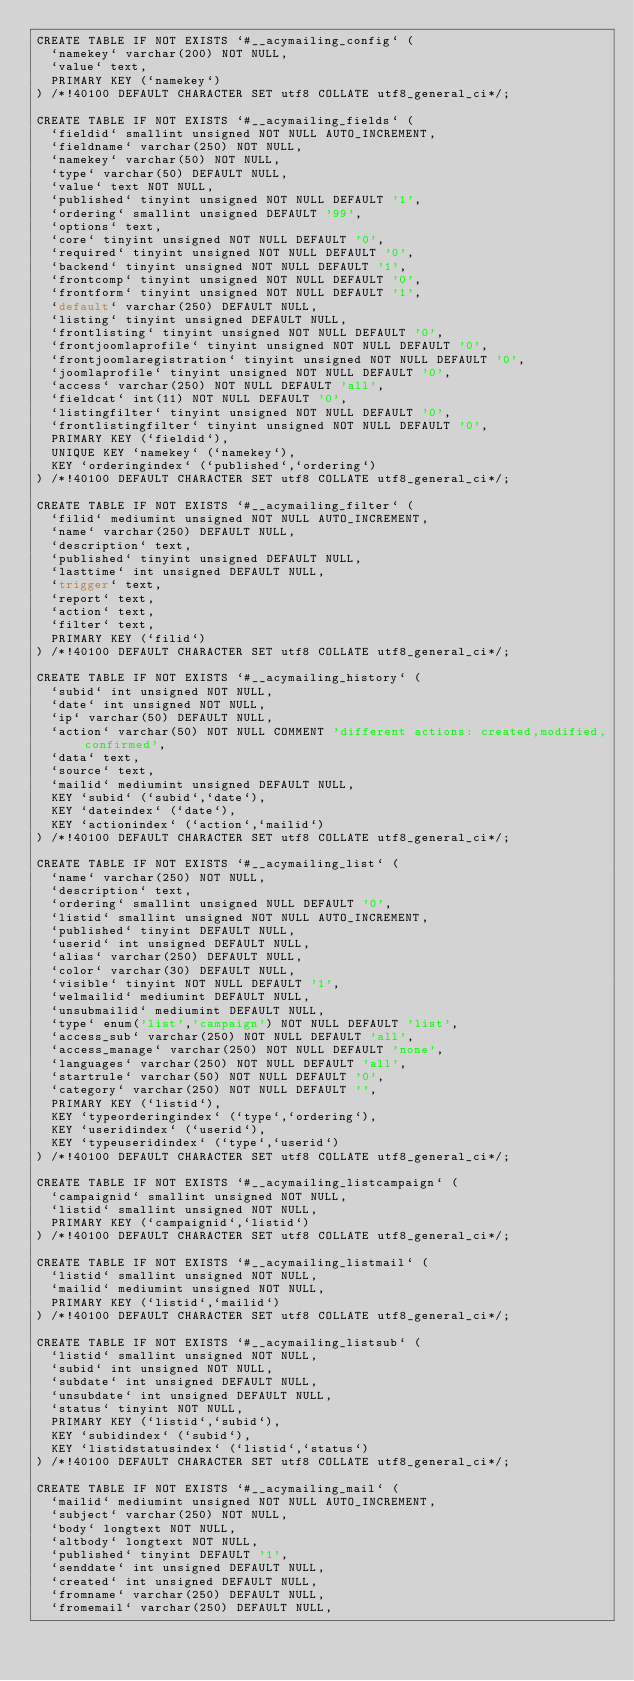Convert code to text. <code><loc_0><loc_0><loc_500><loc_500><_SQL_>CREATE TABLE IF NOT EXISTS `#__acymailing_config` (
	`namekey` varchar(200) NOT NULL,
	`value` text,
	PRIMARY KEY (`namekey`)
) /*!40100 DEFAULT CHARACTER SET utf8 COLLATE utf8_general_ci*/;

CREATE TABLE IF NOT EXISTS `#__acymailing_fields` (
	`fieldid` smallint unsigned NOT NULL AUTO_INCREMENT,
	`fieldname` varchar(250) NOT NULL,
	`namekey` varchar(50) NOT NULL,
	`type` varchar(50) DEFAULT NULL,
	`value` text NOT NULL,
	`published` tinyint unsigned NOT NULL DEFAULT '1',
	`ordering` smallint unsigned DEFAULT '99',
	`options` text,
	`core` tinyint unsigned NOT NULL DEFAULT '0',
	`required` tinyint unsigned NOT NULL DEFAULT '0',
	`backend` tinyint unsigned NOT NULL DEFAULT '1',
	`frontcomp` tinyint unsigned NOT NULL DEFAULT '0',
	`frontform` tinyint unsigned NOT NULL DEFAULT '1',
	`default` varchar(250) DEFAULT NULL,
	`listing` tinyint unsigned DEFAULT NULL,
	`frontlisting` tinyint unsigned NOT NULL DEFAULT '0',
	`frontjoomlaprofile` tinyint unsigned NOT NULL DEFAULT '0',
	`frontjoomlaregistration` tinyint unsigned NOT NULL DEFAULT '0',
	`joomlaprofile` tinyint unsigned NOT NULL DEFAULT '0',
	`access` varchar(250) NOT NULL DEFAULT 'all',
	`fieldcat` int(11) NOT NULL DEFAULT '0',
	`listingfilter` tinyint unsigned NOT NULL DEFAULT '0',
	`frontlistingfilter` tinyint unsigned NOT NULL DEFAULT '0',
	PRIMARY KEY (`fieldid`),
	UNIQUE KEY `namekey` (`namekey`),
	KEY `orderingindex` (`published`,`ordering`)
) /*!40100 DEFAULT CHARACTER SET utf8 COLLATE utf8_general_ci*/;

CREATE TABLE IF NOT EXISTS `#__acymailing_filter` (
	`filid` mediumint unsigned NOT NULL AUTO_INCREMENT,
	`name` varchar(250) DEFAULT NULL,
	`description` text,
	`published` tinyint unsigned DEFAULT NULL,
	`lasttime` int unsigned DEFAULT NULL,
	`trigger` text,
	`report` text,
	`action` text,
	`filter` text,
	PRIMARY KEY (`filid`)
) /*!40100 DEFAULT CHARACTER SET utf8 COLLATE utf8_general_ci*/;

CREATE TABLE IF NOT EXISTS `#__acymailing_history` (
	`subid` int unsigned NOT NULL,
	`date` int unsigned NOT NULL,
	`ip` varchar(50) DEFAULT NULL,
	`action` varchar(50) NOT NULL COMMENT 'different actions: created,modified,confirmed',
	`data` text,
	`source` text,
	`mailid` mediumint unsigned DEFAULT NULL,
	KEY `subid` (`subid`,`date`),
	KEY `dateindex` (`date`),
	KEY `actionindex` (`action`,`mailid`)
) /*!40100 DEFAULT CHARACTER SET utf8 COLLATE utf8_general_ci*/;

CREATE TABLE IF NOT EXISTS `#__acymailing_list` (
	`name` varchar(250) NOT NULL,
	`description` text,
	`ordering` smallint unsigned NULL DEFAULT '0',
	`listid` smallint unsigned NOT NULL AUTO_INCREMENT,
	`published` tinyint DEFAULT NULL,
	`userid` int unsigned DEFAULT NULL,
	`alias` varchar(250) DEFAULT NULL,
	`color` varchar(30) DEFAULT NULL,
	`visible` tinyint NOT NULL DEFAULT '1',
	`welmailid` mediumint DEFAULT NULL,
	`unsubmailid` mediumint DEFAULT NULL,
	`type` enum('list','campaign') NOT NULL DEFAULT 'list',
	`access_sub` varchar(250) NOT NULL DEFAULT 'all',
	`access_manage` varchar(250) NOT NULL DEFAULT 'none',
	`languages` varchar(250) NOT NULL DEFAULT 'all',
	`startrule` varchar(50) NOT NULL DEFAULT '0',
	`category` varchar(250) NOT NULL DEFAULT '',
	PRIMARY KEY (`listid`),
	KEY `typeorderingindex` (`type`,`ordering`),
	KEY `useridindex` (`userid`),
	KEY `typeuseridindex` (`type`,`userid`)
) /*!40100 DEFAULT CHARACTER SET utf8 COLLATE utf8_general_ci*/;

CREATE TABLE IF NOT EXISTS `#__acymailing_listcampaign` (
	`campaignid` smallint unsigned NOT NULL,
	`listid` smallint unsigned NOT NULL,
	PRIMARY KEY (`campaignid`,`listid`)
) /*!40100 DEFAULT CHARACTER SET utf8 COLLATE utf8_general_ci*/;

CREATE TABLE IF NOT EXISTS `#__acymailing_listmail` (
	`listid` smallint unsigned NOT NULL,
	`mailid` mediumint unsigned NOT NULL,
	PRIMARY KEY (`listid`,`mailid`)
) /*!40100 DEFAULT CHARACTER SET utf8 COLLATE utf8_general_ci*/;

CREATE TABLE IF NOT EXISTS `#__acymailing_listsub` (
	`listid` smallint unsigned NOT NULL,
	`subid` int unsigned NOT NULL,
	`subdate` int unsigned DEFAULT NULL,
	`unsubdate` int unsigned DEFAULT NULL,
	`status` tinyint NOT NULL,
	PRIMARY KEY (`listid`,`subid`),
	KEY `subidindex` (`subid`),
	KEY `listidstatusindex` (`listid`,`status`)
) /*!40100 DEFAULT CHARACTER SET utf8 COLLATE utf8_general_ci*/;

CREATE TABLE IF NOT EXISTS `#__acymailing_mail` (
	`mailid` mediumint unsigned NOT NULL AUTO_INCREMENT,
	`subject` varchar(250) NOT NULL,
	`body` longtext NOT NULL,
	`altbody` longtext NOT NULL,
	`published` tinyint DEFAULT '1',
	`senddate` int unsigned DEFAULT NULL,
	`created` int unsigned DEFAULT NULL,
	`fromname` varchar(250) DEFAULT NULL,
	`fromemail` varchar(250) DEFAULT NULL,</code> 